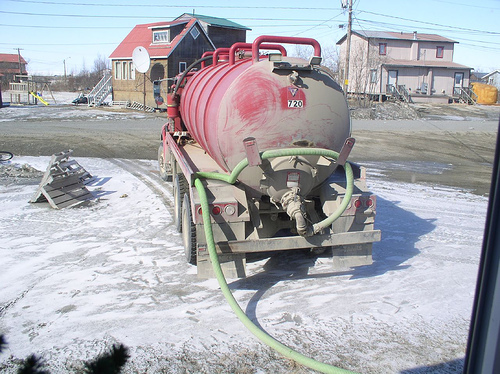<image>
Is there a house behind the satelite dish? Yes. From this viewpoint, the house is positioned behind the satelite dish, with the satelite dish partially or fully occluding the house. Is there a tank to the right of the house? Yes. From this viewpoint, the tank is positioned to the right side relative to the house. 